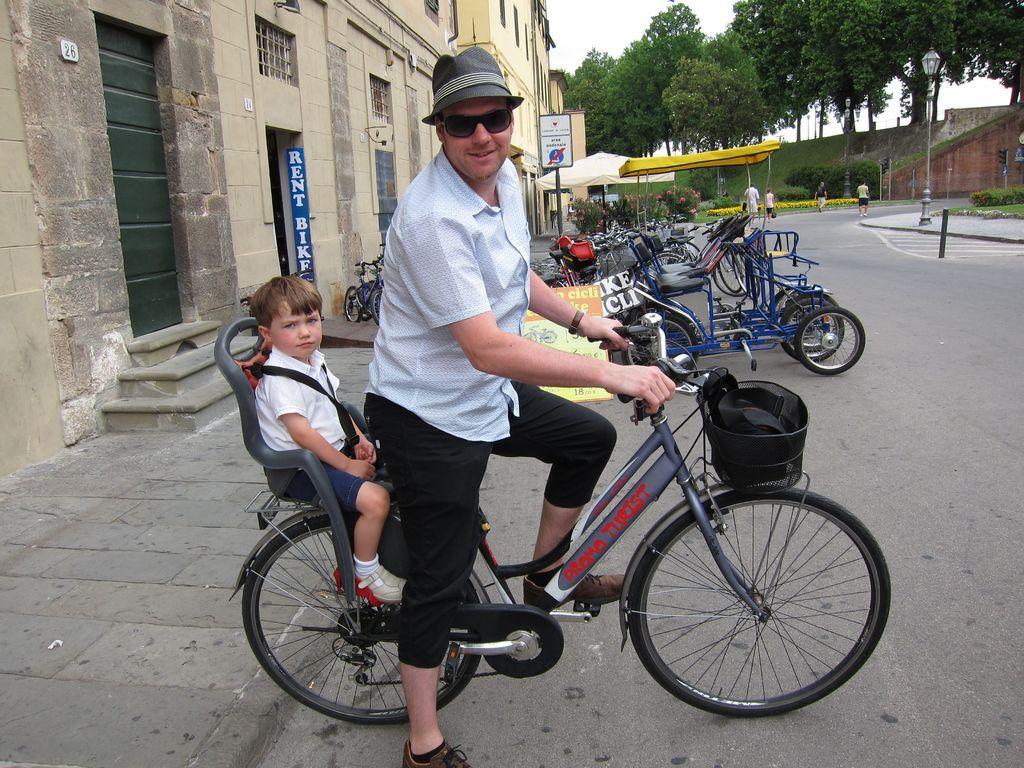Please provide a concise description of this image. In this picture there is a man riding a bicycle, behind him there is a kid sitting on the bicycle. The man is wearing spectacles and hat. There are some vehicles parked in the background. We can observe some trees and buildings here. 